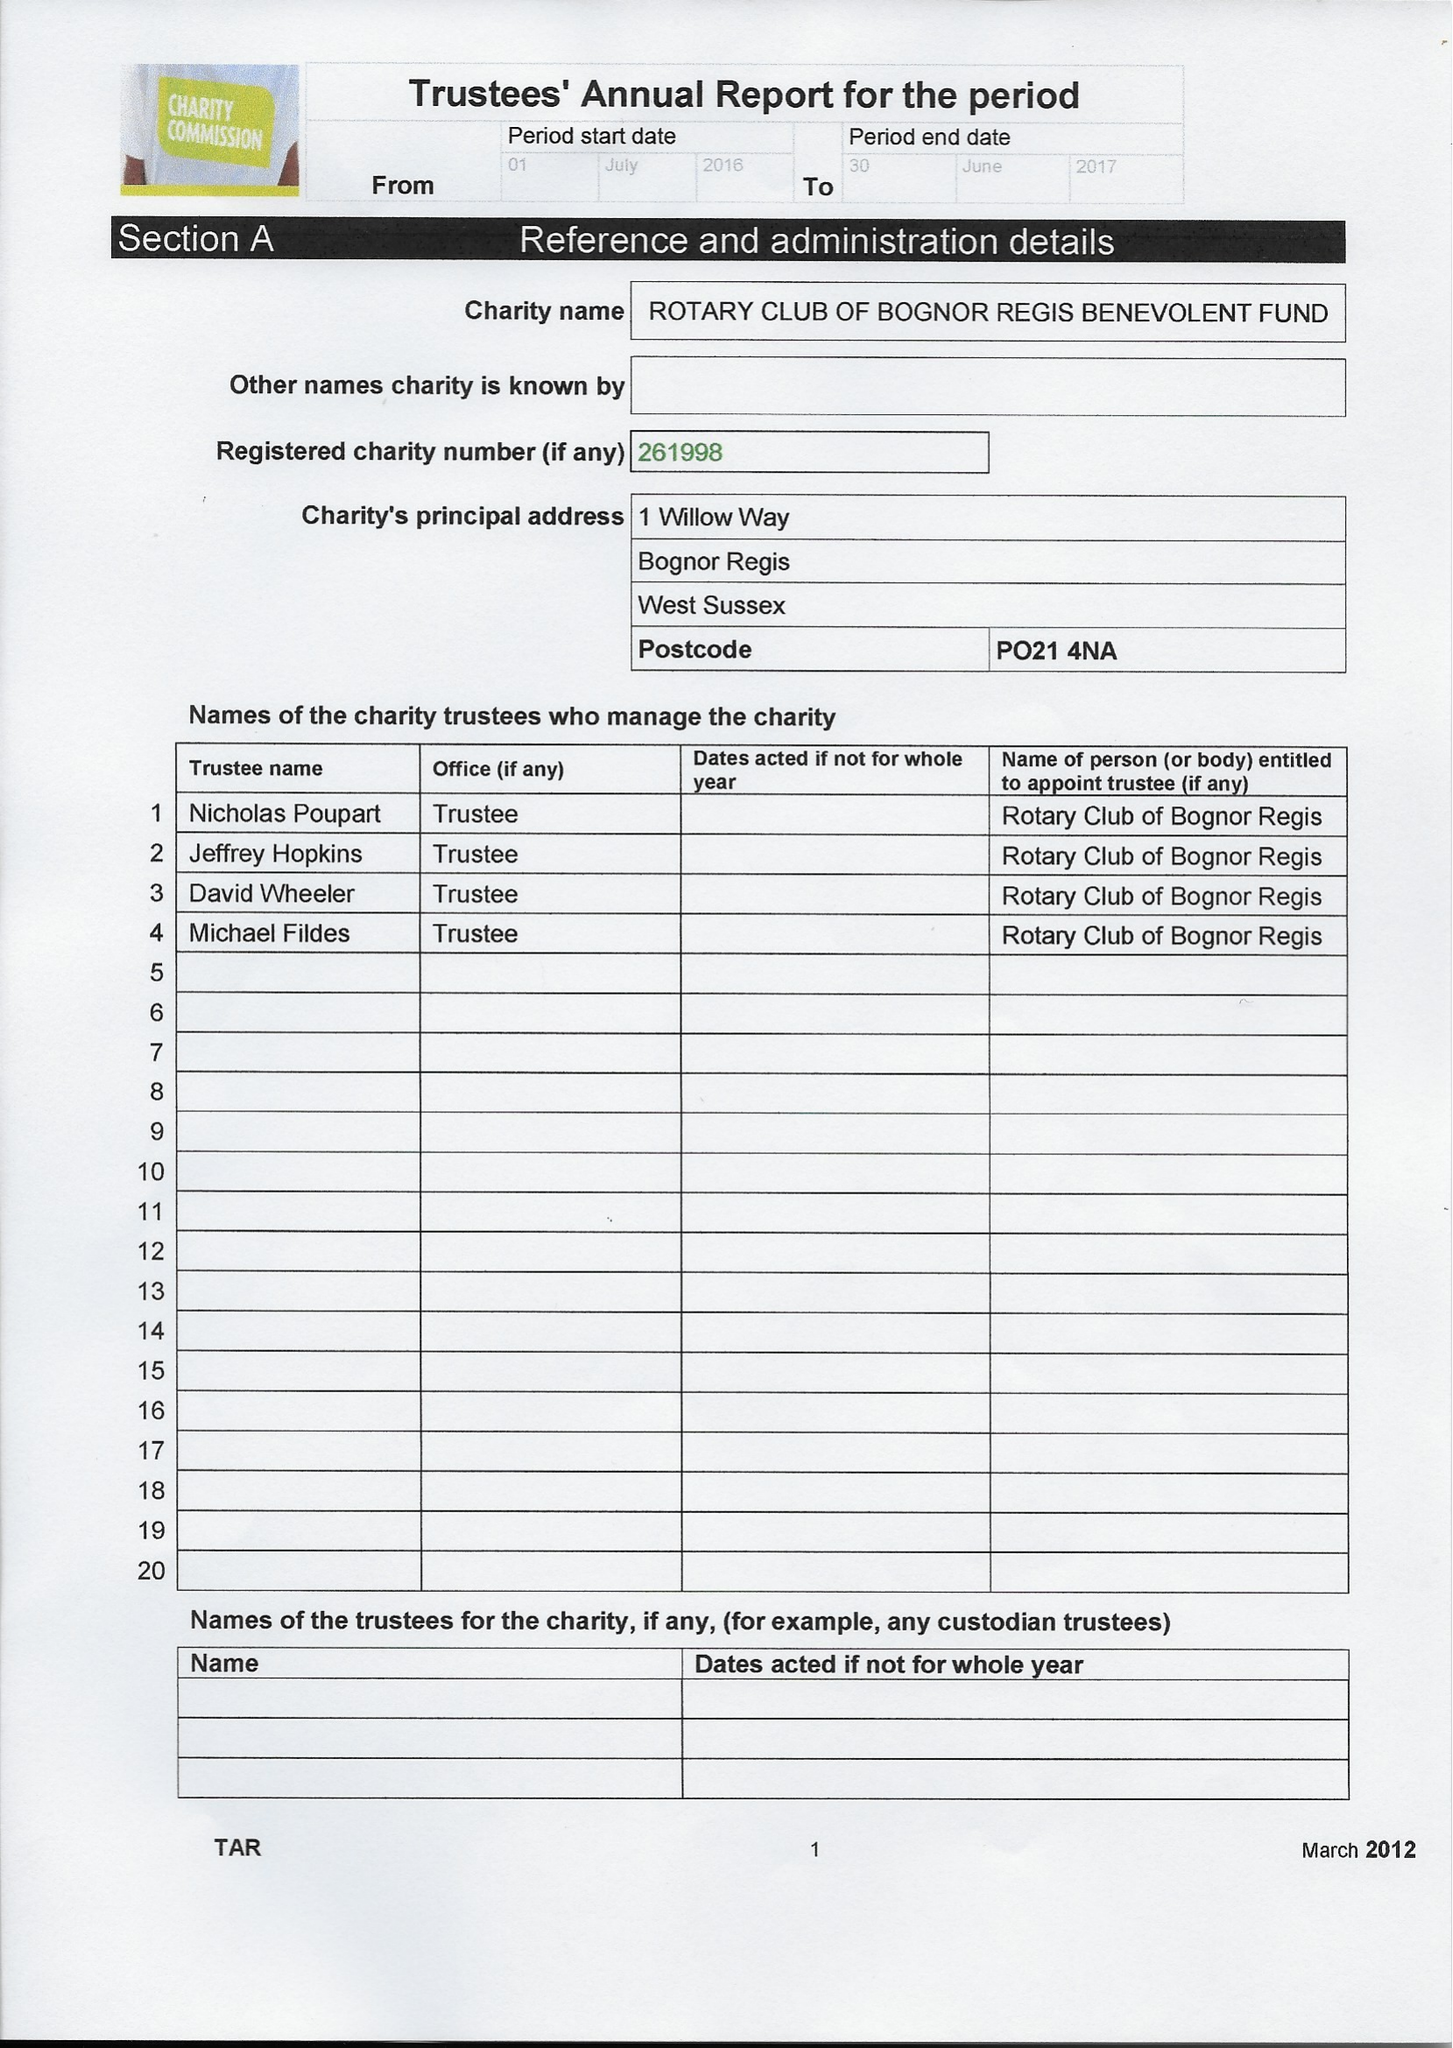What is the value for the charity_name?
Answer the question using a single word or phrase. Rotary Club Of Bognor Regis Benevolent Fund 